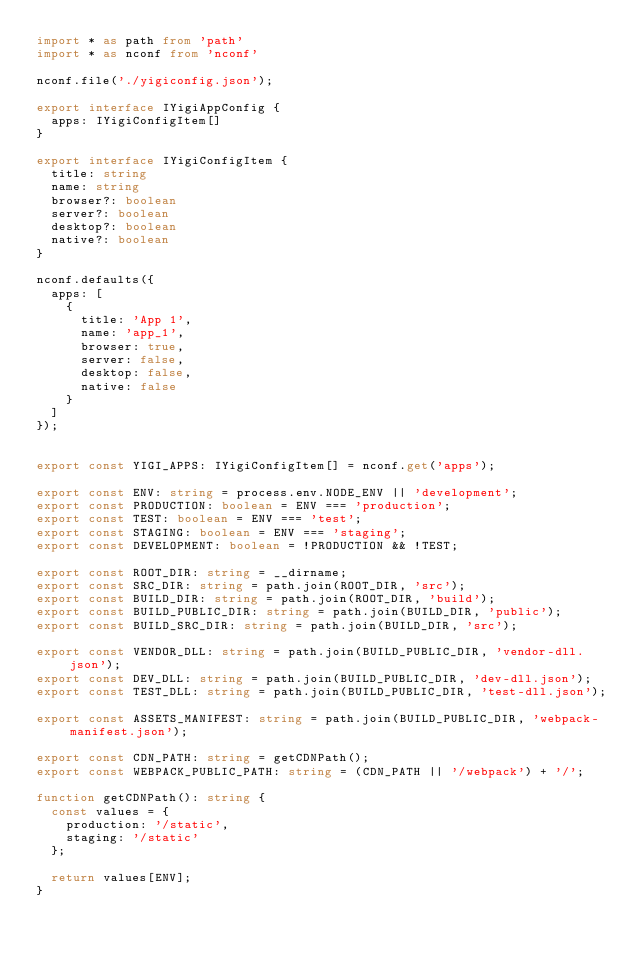Convert code to text. <code><loc_0><loc_0><loc_500><loc_500><_TypeScript_>import * as path from 'path'
import * as nconf from 'nconf'

nconf.file('./yigiconfig.json');

export interface IYigiAppConfig {
  apps: IYigiConfigItem[]
}

export interface IYigiConfigItem {
  title: string
  name: string
  browser?: boolean
  server?: boolean
  desktop?: boolean
  native?: boolean
}

nconf.defaults({
  apps: [
    {
      title: 'App 1',
      name: 'app_1',
      browser: true,
      server: false,
      desktop: false,
      native: false
    }
  ]
});


export const YIGI_APPS: IYigiConfigItem[] = nconf.get('apps');

export const ENV: string = process.env.NODE_ENV || 'development';
export const PRODUCTION: boolean = ENV === 'production';
export const TEST: boolean = ENV === 'test';
export const STAGING: boolean = ENV === 'staging';
export const DEVELOPMENT: boolean = !PRODUCTION && !TEST;

export const ROOT_DIR: string = __dirname;
export const SRC_DIR: string = path.join(ROOT_DIR, 'src');
export const BUILD_DIR: string = path.join(ROOT_DIR, 'build');
export const BUILD_PUBLIC_DIR: string = path.join(BUILD_DIR, 'public');
export const BUILD_SRC_DIR: string = path.join(BUILD_DIR, 'src');

export const VENDOR_DLL: string = path.join(BUILD_PUBLIC_DIR, 'vendor-dll.json');
export const DEV_DLL: string = path.join(BUILD_PUBLIC_DIR, 'dev-dll.json');
export const TEST_DLL: string = path.join(BUILD_PUBLIC_DIR, 'test-dll.json');

export const ASSETS_MANIFEST: string = path.join(BUILD_PUBLIC_DIR, 'webpack-manifest.json');

export const CDN_PATH: string = getCDNPath();
export const WEBPACK_PUBLIC_PATH: string = (CDN_PATH || '/webpack') + '/';

function getCDNPath(): string {
  const values = {
    production: '/static',
    staging: '/static'
  };

  return values[ENV];
}
</code> 